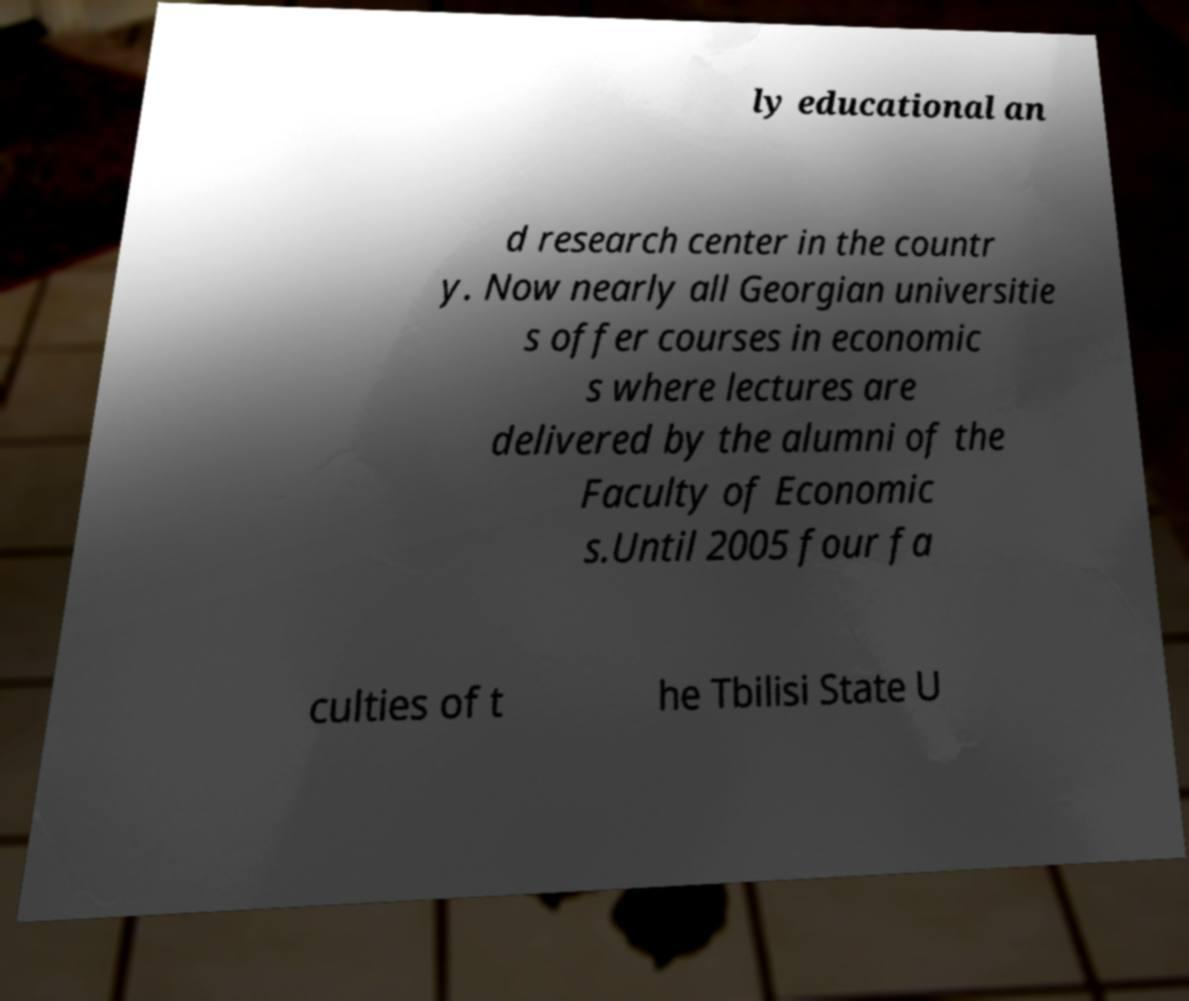For documentation purposes, I need the text within this image transcribed. Could you provide that? ly educational an d research center in the countr y. Now nearly all Georgian universitie s offer courses in economic s where lectures are delivered by the alumni of the Faculty of Economic s.Until 2005 four fa culties of t he Tbilisi State U 